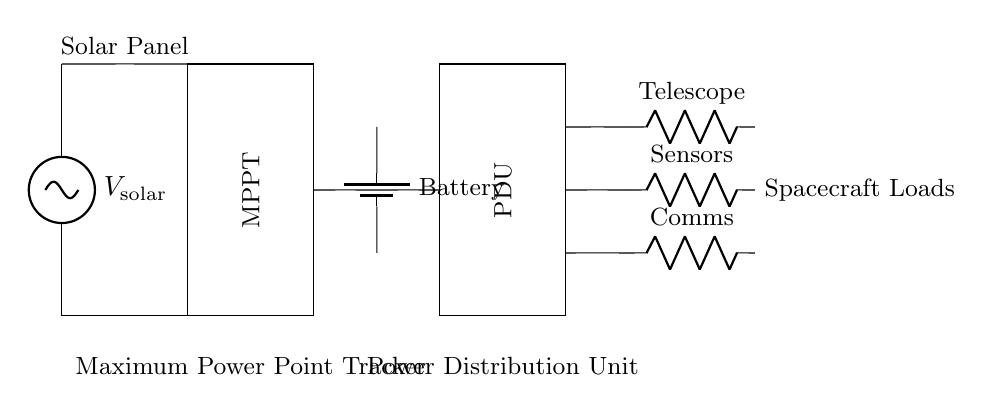What is the primary power source in this circuit? The primary power source is the solar panel, which converts solar energy into electrical energy. It is clearly labeled in the circuit diagram at the left side as "Solar Panel."
Answer: Solar panel What component is used for maximum power extraction? The component used for maximum power extraction is the Maximum Power Point Tracker (MPPT). This component is represented in the diagram and is essential for optimizing the energy harvested from the solar panel.
Answer: MPPT How many loads are connected to the Power Distribution Unit? There are three loads connected to the Power Distribution Unit (PDU). They are labeled as Telescope, Sensors, and Comms in the circuit diagram, clearly showing their connections to the PDU.
Answer: Three Which component stores electrical energy? The component that stores electrical energy is the battery, indicated as "Battery" in the circuit diagram, and positioned between the solar panel setup and the PDU.
Answer: Battery What is the purpose of the Power Distribution Unit in this circuit? The purpose of the Power Distribution Unit (PDU) is to distribute power from the battery to the various loads (Telescope, Sensors, and Comms). The PDU connects directly to the battery and the loads, facilitating efficient power management within the system.
Answer: Distribute power What type of resistors are used for the loads? The loads are represented by resistors in the circuit, specifically labeled as "R" for each load, indicating that they behave as resistive components within this energy management system.
Answer: Resistors What role does the MPPT play in the system configuration? The MPPT optimizes the energy output from the solar panel by adjusting the load seen by the panel to ensure it operates at its maximum power point. This is crucial for enhancing energy efficiency in the power management system.
Answer: Optimize energy output 